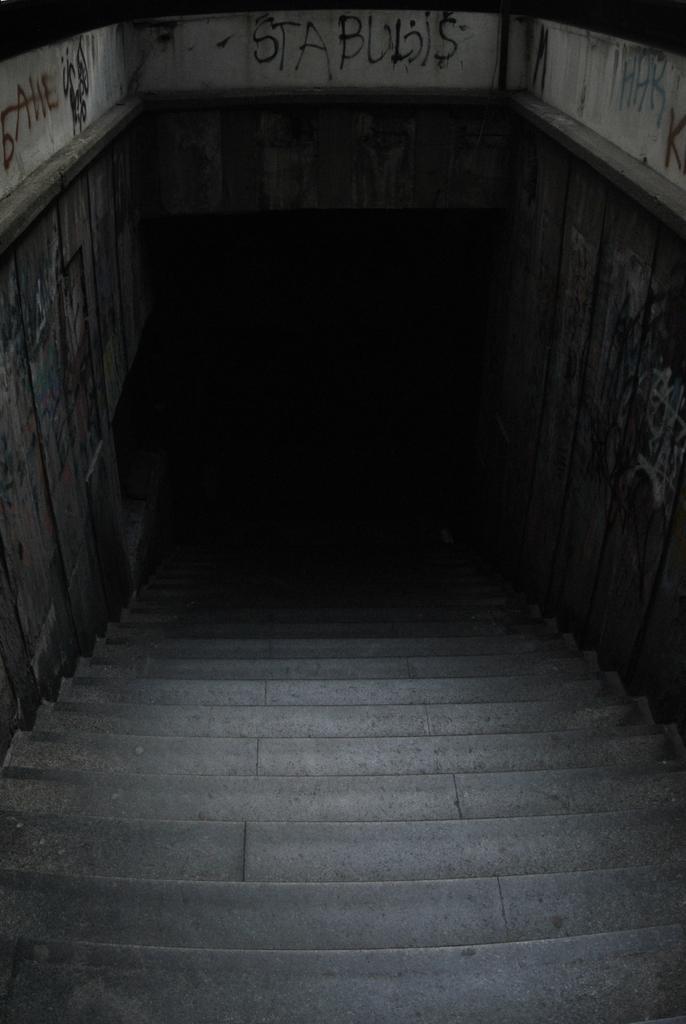How would you summarize this image in a sentence or two? IN this image we can see the stairs, and some texts on the wall. 